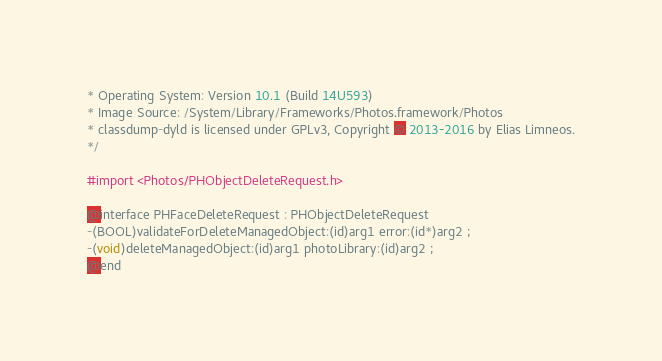Convert code to text. <code><loc_0><loc_0><loc_500><loc_500><_C_>* Operating System: Version 10.1 (Build 14U593)
* Image Source: /System/Library/Frameworks/Photos.framework/Photos
* classdump-dyld is licensed under GPLv3, Copyright © 2013-2016 by Elias Limneos.
*/

#import <Photos/PHObjectDeleteRequest.h>

@interface PHFaceDeleteRequest : PHObjectDeleteRequest
-(BOOL)validateForDeleteManagedObject:(id)arg1 error:(id*)arg2 ;
-(void)deleteManagedObject:(id)arg1 photoLibrary:(id)arg2 ;
@end

</code> 